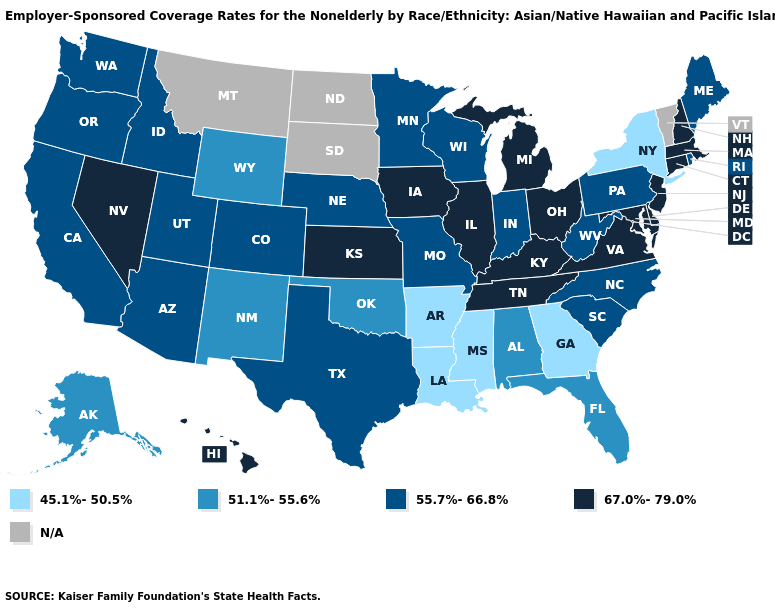What is the lowest value in the South?
Answer briefly. 45.1%-50.5%. Name the states that have a value in the range 67.0%-79.0%?
Answer briefly. Connecticut, Delaware, Hawaii, Illinois, Iowa, Kansas, Kentucky, Maryland, Massachusetts, Michigan, Nevada, New Hampshire, New Jersey, Ohio, Tennessee, Virginia. Does Indiana have the highest value in the MidWest?
Quick response, please. No. What is the lowest value in the Northeast?
Write a very short answer. 45.1%-50.5%. What is the lowest value in the South?
Quick response, please. 45.1%-50.5%. Is the legend a continuous bar?
Keep it brief. No. Name the states that have a value in the range 51.1%-55.6%?
Concise answer only. Alabama, Alaska, Florida, New Mexico, Oklahoma, Wyoming. Does the first symbol in the legend represent the smallest category?
Give a very brief answer. Yes. What is the value of Arizona?
Quick response, please. 55.7%-66.8%. Does the map have missing data?
Answer briefly. Yes. What is the highest value in states that border Arkansas?
Be succinct. 67.0%-79.0%. Which states have the lowest value in the West?
Give a very brief answer. Alaska, New Mexico, Wyoming. 